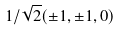<formula> <loc_0><loc_0><loc_500><loc_500>1 / \sqrt { 2 } ( \pm 1 , \pm 1 , 0 )</formula> 